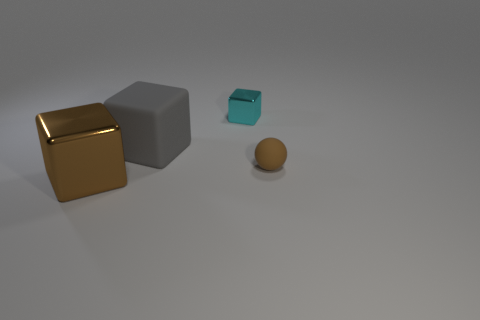How many large brown things are the same shape as the gray rubber object?
Offer a very short reply. 1. What number of tiny metal cubes are there?
Your response must be concise. 1. There is a shiny block that is in front of the small block; what color is it?
Your answer should be compact. Brown. There is a cube in front of the brown thing that is right of the large metal thing; what is its color?
Your response must be concise. Brown. The block that is the same size as the ball is what color?
Provide a short and direct response. Cyan. How many shiny blocks are both to the right of the gray matte thing and in front of the large gray rubber thing?
Keep it short and to the point. 0. The other thing that is the same color as the large shiny object is what shape?
Provide a succinct answer. Sphere. What material is the object that is on the right side of the large matte thing and behind the tiny brown rubber sphere?
Ensure brevity in your answer.  Metal. Is the number of large brown metal blocks that are in front of the cyan shiny block less than the number of metallic cubes in front of the big gray rubber object?
Your answer should be compact. No. What size is the other object that is the same material as the large gray thing?
Provide a short and direct response. Small. 